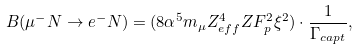Convert formula to latex. <formula><loc_0><loc_0><loc_500><loc_500>B ( \mu ^ { - } N \rightarrow e ^ { - } N ) = ( 8 \alpha ^ { 5 } m _ { \mu } Z _ { e f f } ^ { 4 } Z F _ { p } ^ { 2 } \xi ^ { 2 } ) \cdot { \frac { 1 } { \Gamma _ { c a p t } } } ,</formula> 